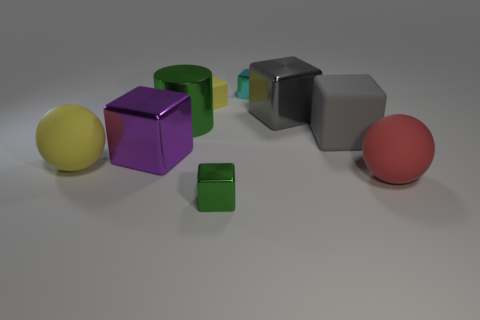What shape is the matte object that is on the right side of the tiny rubber thing and to the left of the red rubber sphere? cube 